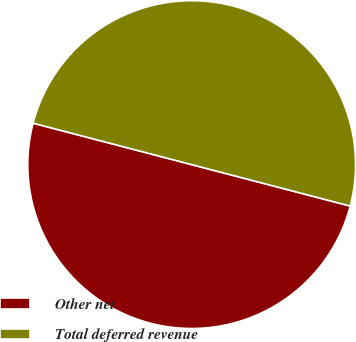Convert chart. <chart><loc_0><loc_0><loc_500><loc_500><pie_chart><fcel>Other net<fcel>Total deferred revenue<nl><fcel>50.0%<fcel>50.0%<nl></chart> 